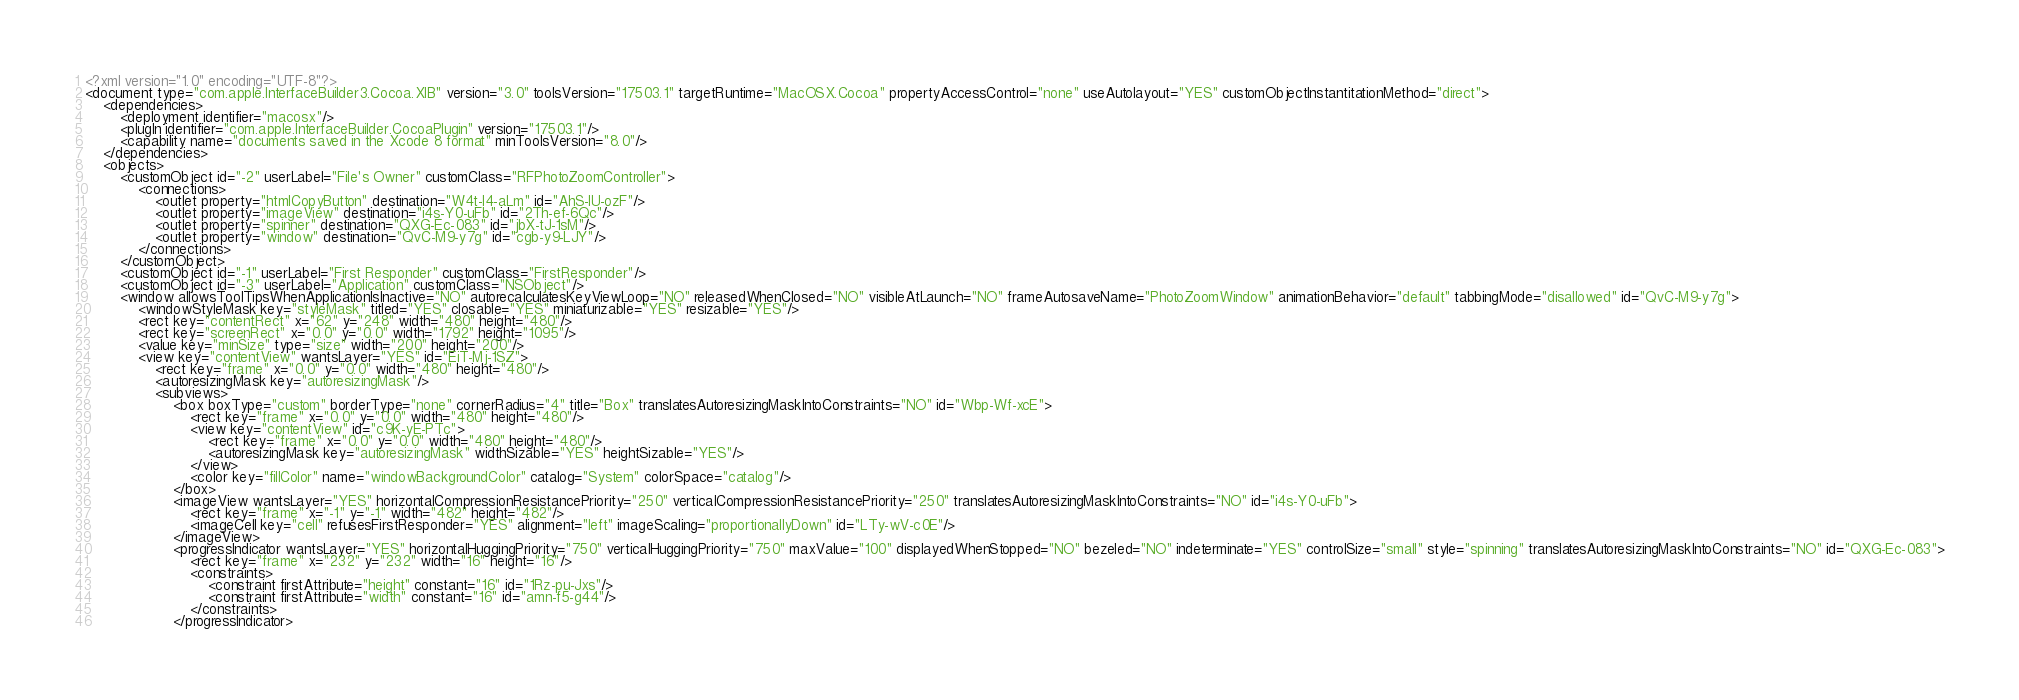Convert code to text. <code><loc_0><loc_0><loc_500><loc_500><_XML_><?xml version="1.0" encoding="UTF-8"?>
<document type="com.apple.InterfaceBuilder3.Cocoa.XIB" version="3.0" toolsVersion="17503.1" targetRuntime="MacOSX.Cocoa" propertyAccessControl="none" useAutolayout="YES" customObjectInstantitationMethod="direct">
    <dependencies>
        <deployment identifier="macosx"/>
        <plugIn identifier="com.apple.InterfaceBuilder.CocoaPlugin" version="17503.1"/>
        <capability name="documents saved in the Xcode 8 format" minToolsVersion="8.0"/>
    </dependencies>
    <objects>
        <customObject id="-2" userLabel="File's Owner" customClass="RFPhotoZoomController">
            <connections>
                <outlet property="htmlCopyButton" destination="W4t-I4-aLm" id="AhS-IU-ozF"/>
                <outlet property="imageView" destination="i4s-Y0-uFb" id="2Th-ef-6Qc"/>
                <outlet property="spinner" destination="QXG-Ec-083" id="jbX-tJ-1sM"/>
                <outlet property="window" destination="QvC-M9-y7g" id="cgb-y9-LJY"/>
            </connections>
        </customObject>
        <customObject id="-1" userLabel="First Responder" customClass="FirstResponder"/>
        <customObject id="-3" userLabel="Application" customClass="NSObject"/>
        <window allowsToolTipsWhenApplicationIsInactive="NO" autorecalculatesKeyViewLoop="NO" releasedWhenClosed="NO" visibleAtLaunch="NO" frameAutosaveName="PhotoZoomWindow" animationBehavior="default" tabbingMode="disallowed" id="QvC-M9-y7g">
            <windowStyleMask key="styleMask" titled="YES" closable="YES" miniaturizable="YES" resizable="YES"/>
            <rect key="contentRect" x="62" y="248" width="480" height="480"/>
            <rect key="screenRect" x="0.0" y="0.0" width="1792" height="1095"/>
            <value key="minSize" type="size" width="200" height="200"/>
            <view key="contentView" wantsLayer="YES" id="EiT-Mj-1SZ">
                <rect key="frame" x="0.0" y="0.0" width="480" height="480"/>
                <autoresizingMask key="autoresizingMask"/>
                <subviews>
                    <box boxType="custom" borderType="none" cornerRadius="4" title="Box" translatesAutoresizingMaskIntoConstraints="NO" id="Wbp-Wf-xcE">
                        <rect key="frame" x="0.0" y="0.0" width="480" height="480"/>
                        <view key="contentView" id="c9K-yE-PTc">
                            <rect key="frame" x="0.0" y="0.0" width="480" height="480"/>
                            <autoresizingMask key="autoresizingMask" widthSizable="YES" heightSizable="YES"/>
                        </view>
                        <color key="fillColor" name="windowBackgroundColor" catalog="System" colorSpace="catalog"/>
                    </box>
                    <imageView wantsLayer="YES" horizontalCompressionResistancePriority="250" verticalCompressionResistancePriority="250" translatesAutoresizingMaskIntoConstraints="NO" id="i4s-Y0-uFb">
                        <rect key="frame" x="-1" y="-1" width="482" height="482"/>
                        <imageCell key="cell" refusesFirstResponder="YES" alignment="left" imageScaling="proportionallyDown" id="LTy-wV-c0E"/>
                    </imageView>
                    <progressIndicator wantsLayer="YES" horizontalHuggingPriority="750" verticalHuggingPriority="750" maxValue="100" displayedWhenStopped="NO" bezeled="NO" indeterminate="YES" controlSize="small" style="spinning" translatesAutoresizingMaskIntoConstraints="NO" id="QXG-Ec-083">
                        <rect key="frame" x="232" y="232" width="16" height="16"/>
                        <constraints>
                            <constraint firstAttribute="height" constant="16" id="1Rz-pu-Jxs"/>
                            <constraint firstAttribute="width" constant="16" id="amn-f5-g44"/>
                        </constraints>
                    </progressIndicator></code> 